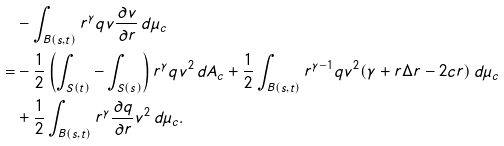Convert formula to latex. <formula><loc_0><loc_0><loc_500><loc_500>& - \int _ { B ( s , t ) } r ^ { \gamma } q v \frac { \partial v } { \partial r } \, d \mu _ { c } \\ = & - \frac { 1 } { 2 } \left ( \int _ { S ( t ) } - \int _ { S ( s ) } \right ) r ^ { \gamma } q v ^ { 2 } \, d A _ { c } + \frac { 1 } { 2 } \int _ { B ( s , t ) } r ^ { \gamma - 1 } q v ^ { 2 } ( \gamma + r \Delta r - 2 c r ) \, d \mu _ { c } \\ & + \frac { 1 } { 2 } \int _ { B ( s , t ) } r ^ { \gamma } \frac { \partial q } { \partial r } v ^ { 2 } \, d \mu _ { c } .</formula> 